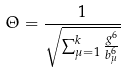<formula> <loc_0><loc_0><loc_500><loc_500>\Theta = \frac { 1 } { \sqrt { \sum _ { \mu = 1 } ^ { k } \frac { g ^ { 6 } } { b _ { \mu } ^ { 6 } } } }</formula> 